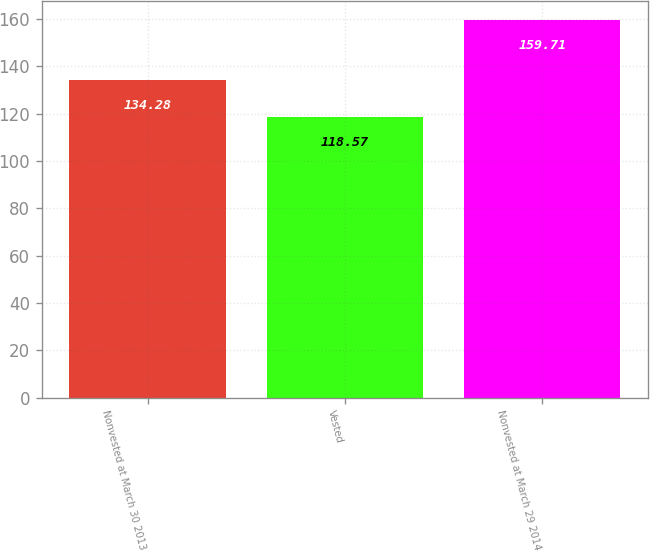Convert chart. <chart><loc_0><loc_0><loc_500><loc_500><bar_chart><fcel>Nonvested at March 30 2013<fcel>Vested<fcel>Nonvested at March 29 2014<nl><fcel>134.28<fcel>118.57<fcel>159.71<nl></chart> 